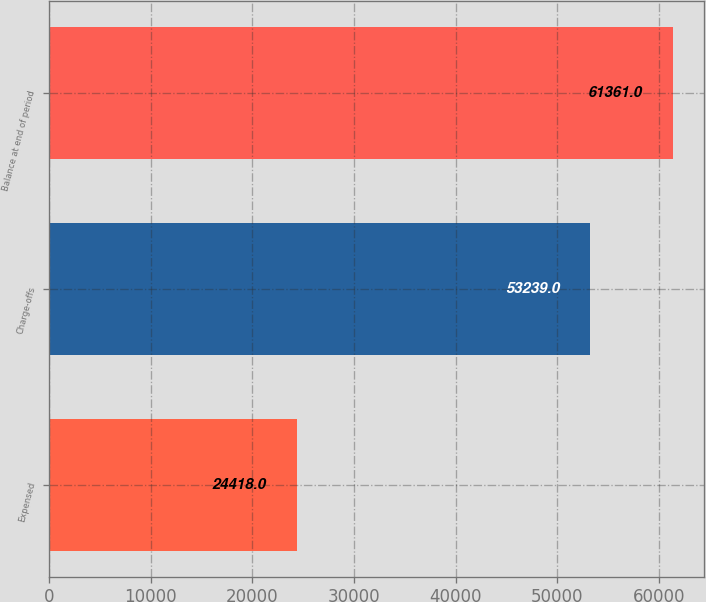Convert chart to OTSL. <chart><loc_0><loc_0><loc_500><loc_500><bar_chart><fcel>Expensed<fcel>Charge-offs<fcel>Balance at end of period<nl><fcel>24418<fcel>53239<fcel>61361<nl></chart> 